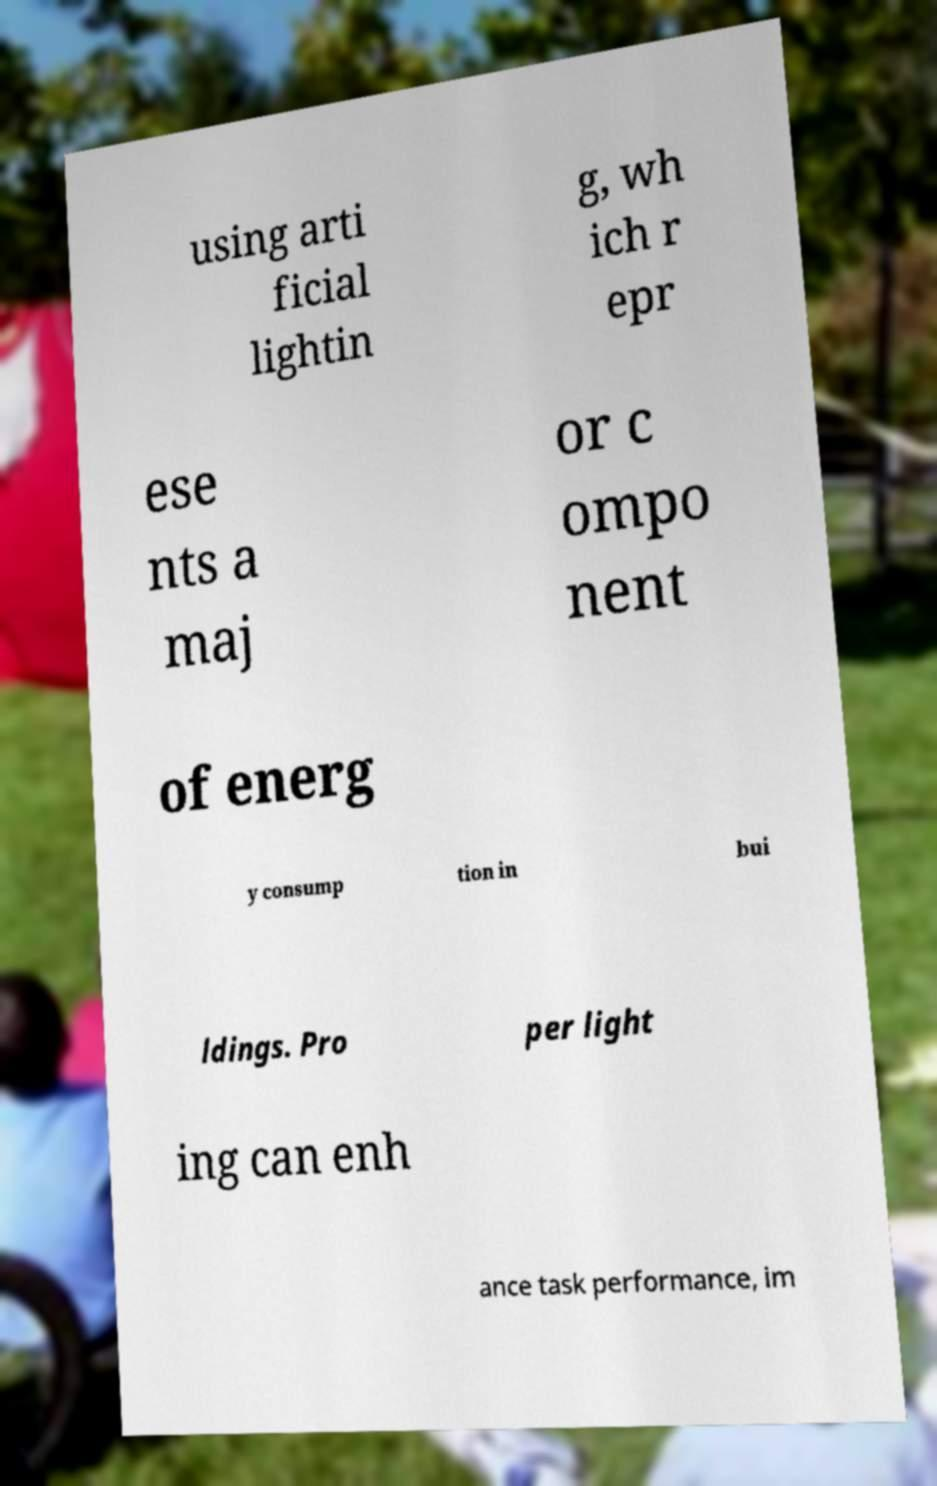Could you assist in decoding the text presented in this image and type it out clearly? using arti ficial lightin g, wh ich r epr ese nts a maj or c ompo nent of energ y consump tion in bui ldings. Pro per light ing can enh ance task performance, im 